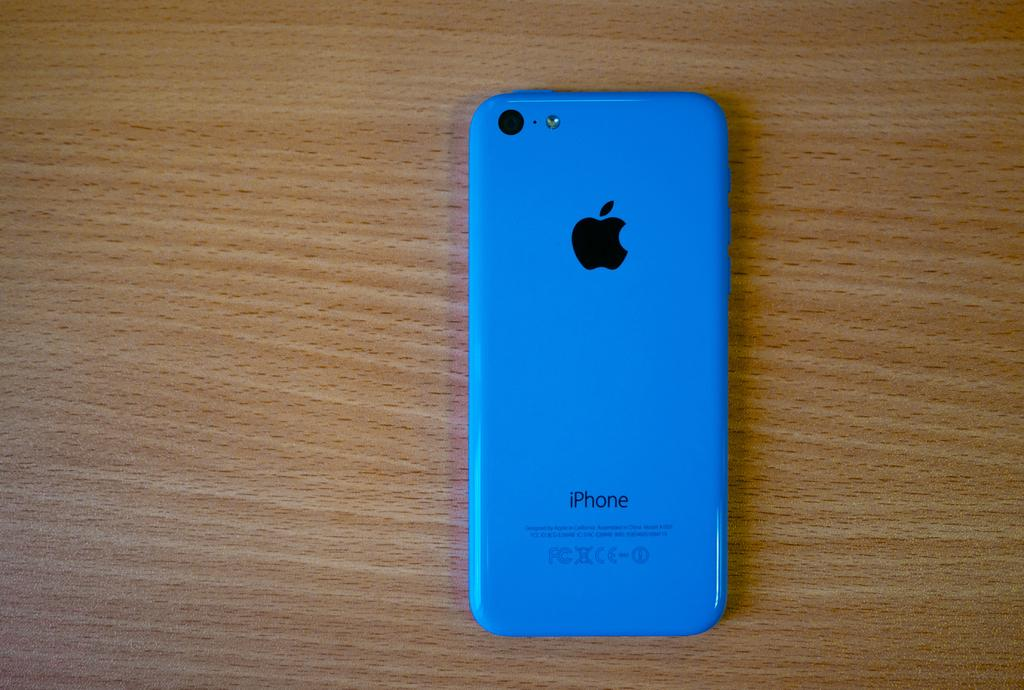Provide a one-sentence caption for the provided image. A blue iPhone sits face down on a wood table. 